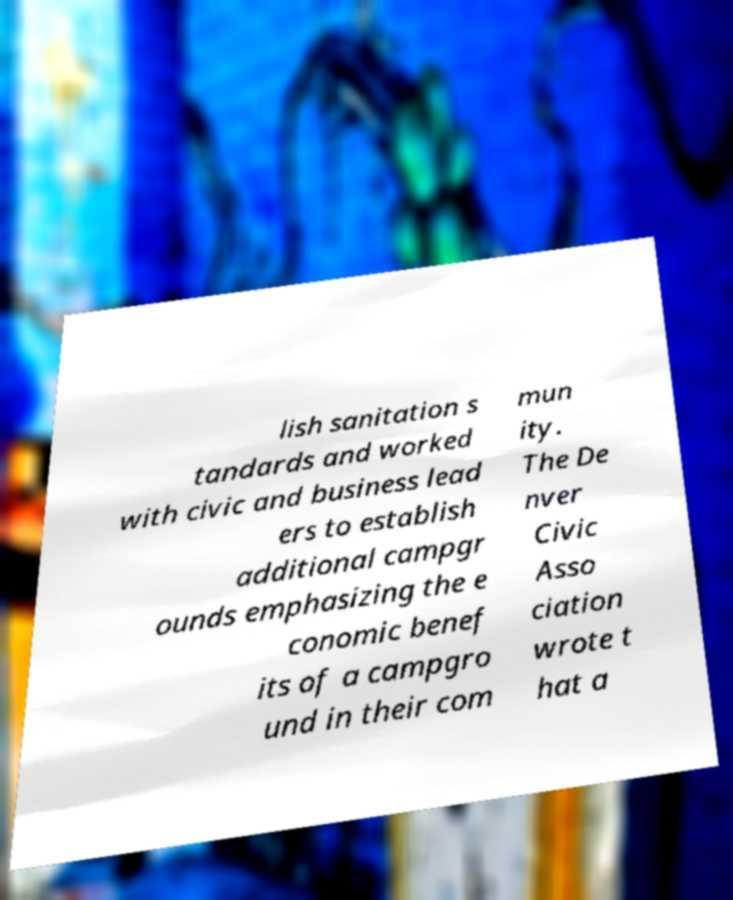For documentation purposes, I need the text within this image transcribed. Could you provide that? lish sanitation s tandards and worked with civic and business lead ers to establish additional campgr ounds emphasizing the e conomic benef its of a campgro und in their com mun ity. The De nver Civic Asso ciation wrote t hat a 